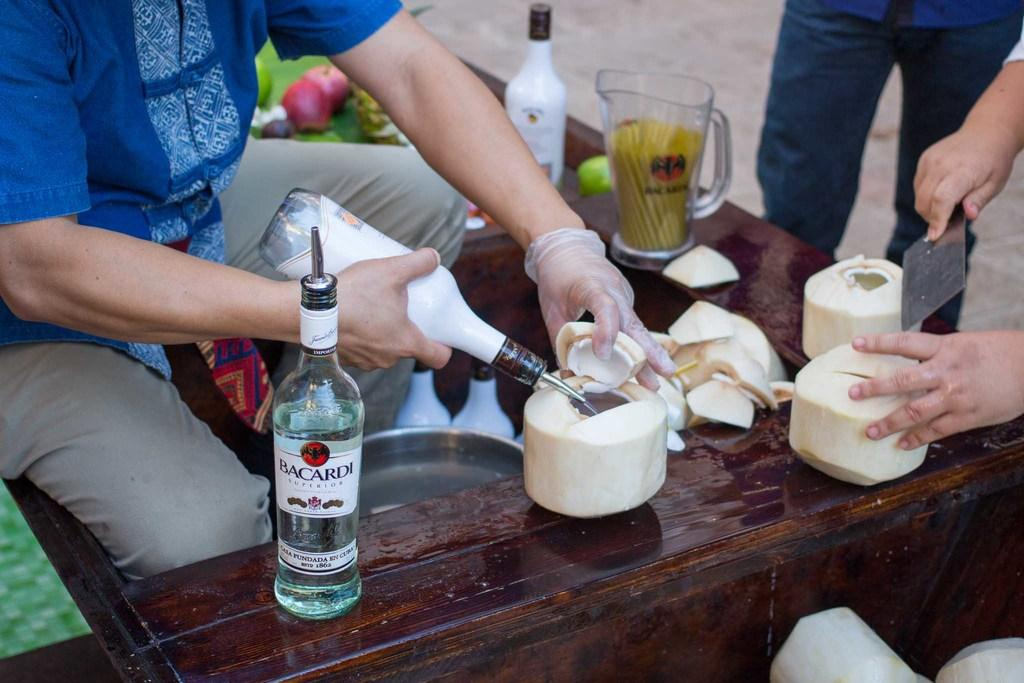Provide a one-sentence caption for the provided image. People cut open coconuts and a bottle of Bacardi sits next to them. 